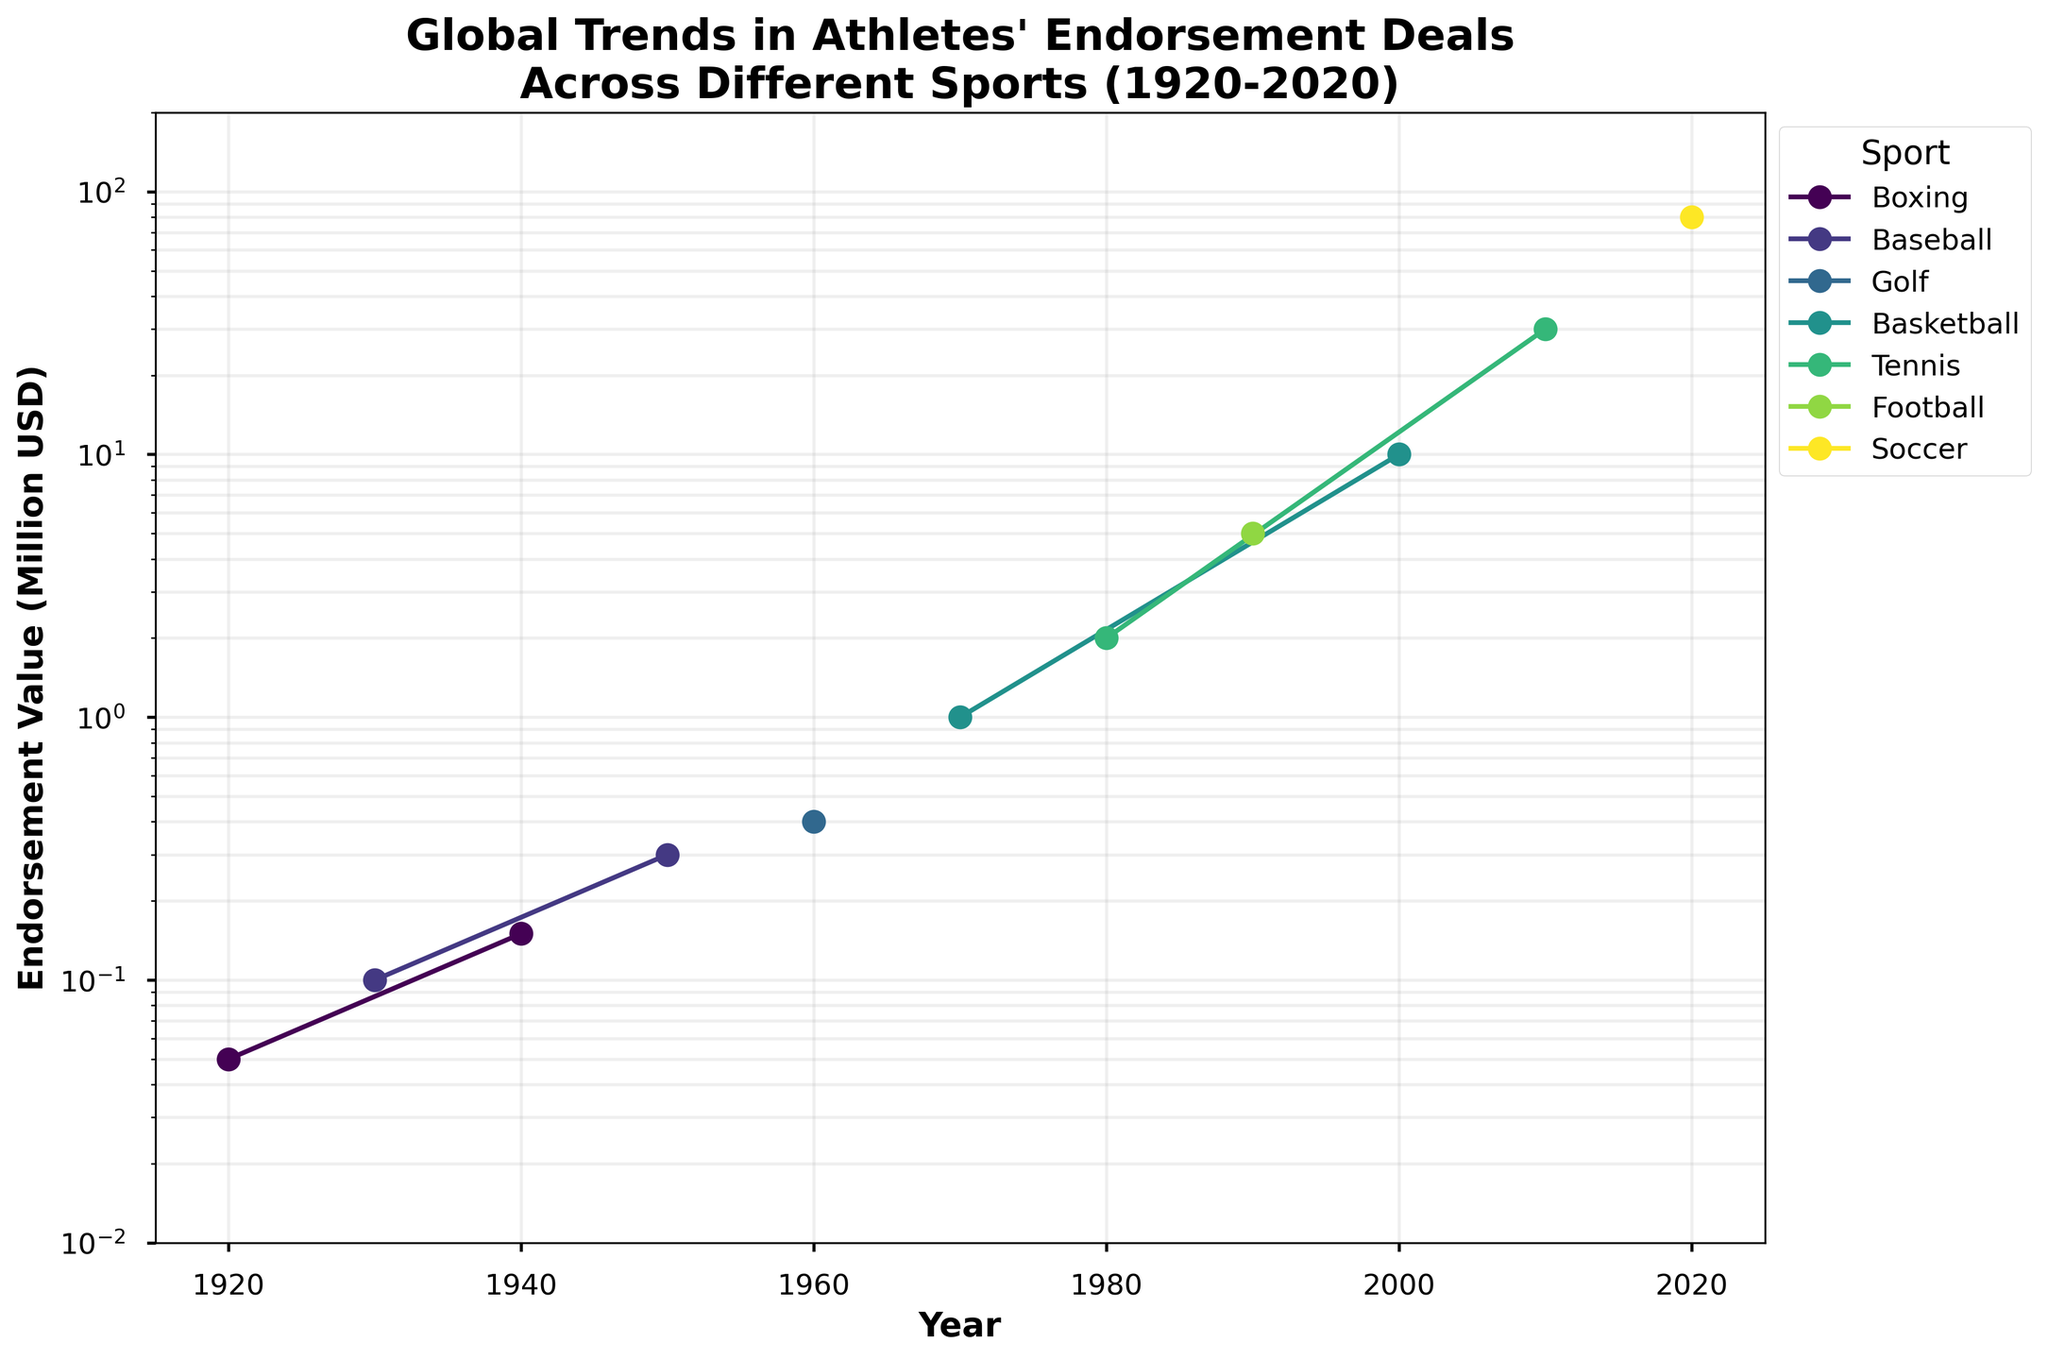What is the title of the plot? The title is displayed at the top of the plot and summarizes what the plot is about. It reads "Global Trends in Athletes' Endorsement Deals Across Different Sports (1920-2020)."
Answer: Global Trends in Athletes' Endorsement Deals Across Different Sports (1920-2020) What year has the highest endorsement value and for which sport? Look at the highest point on the y-axis, which represents the endorsement value, and trace it back to the corresponding year and sport.
Answer: 2020, Soccer Which sport shows the first significant increase in endorsement value? Looking along the x-axis (time) and observing the y-axis (endorsement values), identify which sport's curve first rises significantly. This occurs around 1950 for Baseball.
Answer: Baseball How many sports are represented in the plot? Each sport is denoted by a different colored line, and the legend lists all the sports. Count the sports listed in the legend.
Answer: 7 What's the range of endorsement values in the plot? The y-axis shows the range of endorsement values, starting from the lowest to the highest values represented. The y-axis ranges from 0.01 to 200 million USD.
Answer: 0.01 to 200 million USD Which year marks the first time an endorsement value surpasses 1 million USD? Trace the y-axis to find the 1 million mark and follow horizontally to see the corresponding year and sport that first crosses this threshold.
Answer: 1970 Compare the endorsement value trends in Tennis and Basketball. Which sport exhibits a steeper increase from 2000 to 2020? Look at the slopes of the lines representing Tennis and Basketball between 2000 and 2020. The slope indicates the rate of change, with a steeper slope showing a faster increase.
Answer: Tennis Between 1920 and 1950, which sport had the highest increase in endorsement value? Calculate the differences in endorsement values for each sport in this period and identify the highest value. The increase for Boxing is from 0.05 million USD to 0.15 million USD, so the increase is -> 0.1 million USD.
Answer: Boxing What is the endorsement value for Basketball in the year 2000? Locate the 2000 mark on the x-axis and see the endorsement value on the y-axis for the line representing Basketball.
Answer: 10 million USD How does the endorsement value for Baseball in 1930 compare to Boxing in 1920? Compare the value of endorsement deals for two given points. For Baseball in 1930, it's 0.1, and for Boxing in 1920, it's 0.05.
Answer: Baseball's value is higher 